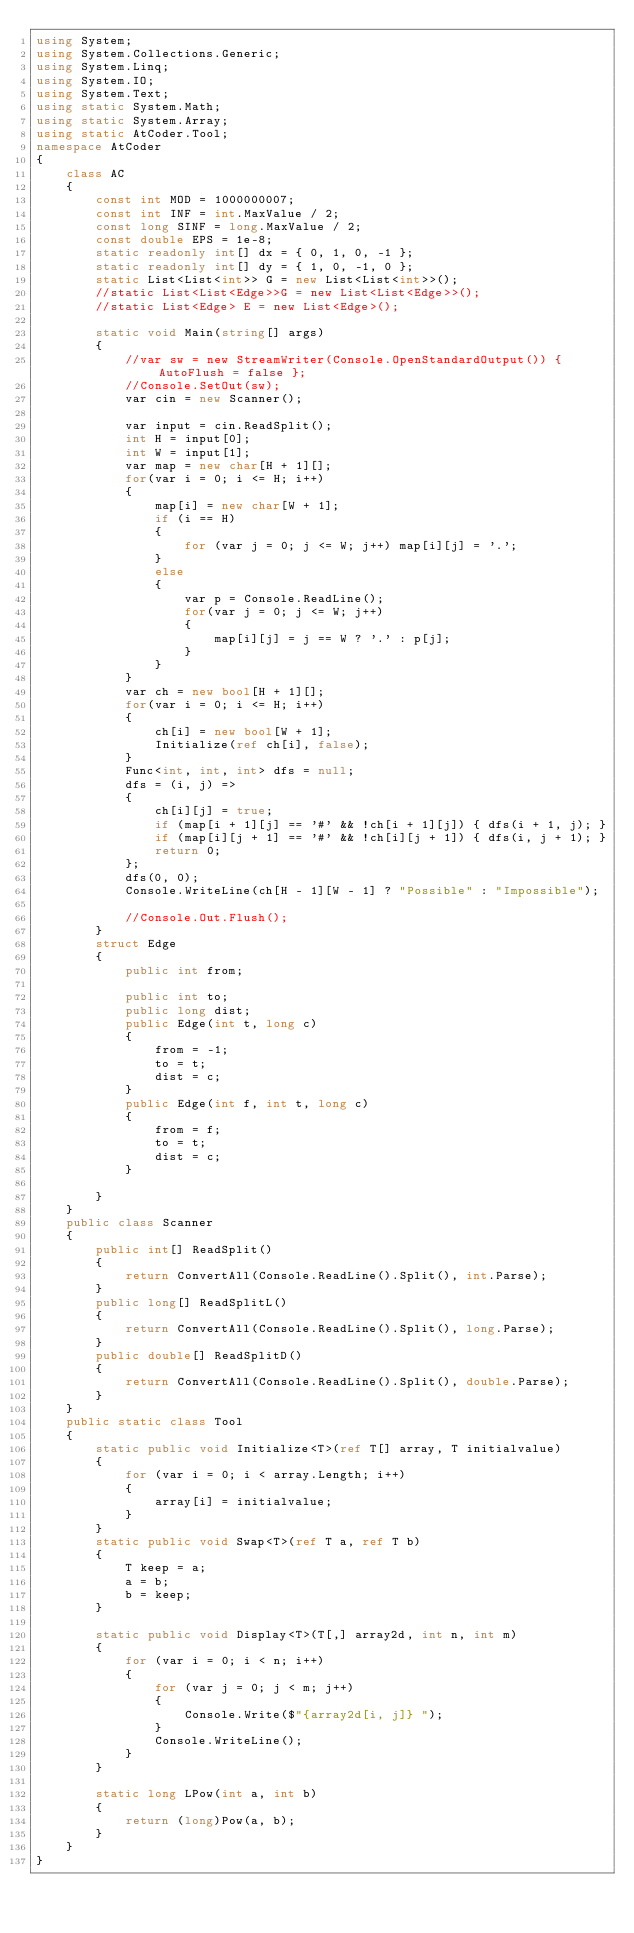Convert code to text. <code><loc_0><loc_0><loc_500><loc_500><_C#_>using System;
using System.Collections.Generic;
using System.Linq;
using System.IO;
using System.Text;
using static System.Math;
using static System.Array;
using static AtCoder.Tool;
namespace AtCoder
{
    class AC
    {
        const int MOD = 1000000007;
        const int INF = int.MaxValue / 2;
        const long SINF = long.MaxValue / 2;
        const double EPS = 1e-8;
        static readonly int[] dx = { 0, 1, 0, -1 };
        static readonly int[] dy = { 1, 0, -1, 0 };
        static List<List<int>> G = new List<List<int>>();
        //static List<List<Edge>>G = new List<List<Edge>>();
        //static List<Edge> E = new List<Edge>();

        static void Main(string[] args)
        {
            //var sw = new StreamWriter(Console.OpenStandardOutput()) { AutoFlush = false };
            //Console.SetOut(sw);
            var cin = new Scanner();

            var input = cin.ReadSplit();
            int H = input[0];
            int W = input[1];
            var map = new char[H + 1][];
            for(var i = 0; i <= H; i++)
            {
                map[i] = new char[W + 1];
                if (i == H)
                {
                    for (var j = 0; j <= W; j++) map[i][j] = '.';
                }
                else
                {
                    var p = Console.ReadLine();
                    for(var j = 0; j <= W; j++)
                    {
                        map[i][j] = j == W ? '.' : p[j];
                    }
                }
            }
            var ch = new bool[H + 1][];
            for(var i = 0; i <= H; i++)
            {
                ch[i] = new bool[W + 1];
                Initialize(ref ch[i], false);
            }
            Func<int, int, int> dfs = null;
            dfs = (i, j) =>
            {
                ch[i][j] = true;
                if (map[i + 1][j] == '#' && !ch[i + 1][j]) { dfs(i + 1, j); }
                if (map[i][j + 1] == '#' && !ch[i][j + 1]) { dfs(i, j + 1); }
                return 0;
            };
            dfs(0, 0);
            Console.WriteLine(ch[H - 1][W - 1] ? "Possible" : "Impossible");

            //Console.Out.Flush();
        }
        struct Edge
        {
            public int from;

            public int to;
            public long dist;
            public Edge(int t, long c)
            {
                from = -1;
                to = t;
                dist = c;
            }
            public Edge(int f, int t, long c)
            {
                from = f;
                to = t;
                dist = c;
            }

        }
    }
    public class Scanner
    {
        public int[] ReadSplit()
        {
            return ConvertAll(Console.ReadLine().Split(), int.Parse);
        }
        public long[] ReadSplitL()
        {
            return ConvertAll(Console.ReadLine().Split(), long.Parse);
        }
        public double[] ReadSplitD()
        {
            return ConvertAll(Console.ReadLine().Split(), double.Parse);
        }
    }
    public static class Tool
    {
        static public void Initialize<T>(ref T[] array, T initialvalue)
        {
            for (var i = 0; i < array.Length; i++)
            {
                array[i] = initialvalue;
            }
        }
        static public void Swap<T>(ref T a, ref T b)
        {
            T keep = a;
            a = b;
            b = keep;
        }

        static public void Display<T>(T[,] array2d, int n, int m)
        {
            for (var i = 0; i < n; i++)
            {
                for (var j = 0; j < m; j++)
                {
                    Console.Write($"{array2d[i, j]} ");
                }
                Console.WriteLine();
            }
        }

        static long LPow(int a, int b)
        {
            return (long)Pow(a, b);
        }
    }
}
</code> 